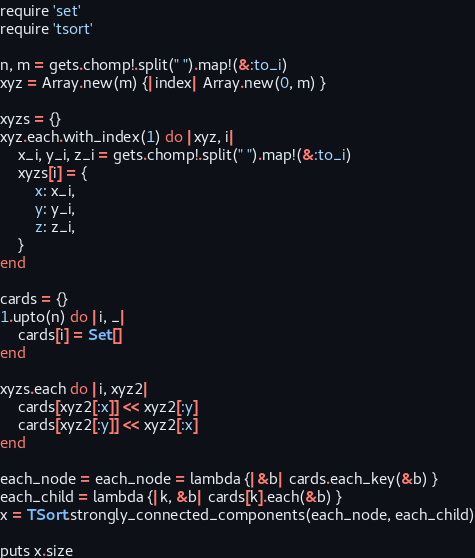<code> <loc_0><loc_0><loc_500><loc_500><_Ruby_>require 'set'
require 'tsort'

n, m = gets.chomp!.split(" ").map!(&:to_i)
xyz = Array.new(m) {|index| Array.new(0, m) }

xyzs = {}
xyz.each.with_index(1) do |xyz, i|
    x_i, y_i, z_i = gets.chomp!.split(" ").map!(&:to_i)
    xyzs[i] = {
        x: x_i,
        y: y_i,
        z: z_i,
    }
end

cards = {}
1.upto(n) do |i, _|
    cards[i] = Set[]
end

xyzs.each do |i, xyz2|
    cards[xyz2[:x]] << xyz2[:y] 
    cards[xyz2[:y]] << xyz2[:x]
end

each_node = each_node = lambda {|&b| cards.each_key(&b) }
each_child = lambda {|k, &b| cards[k].each(&b) }
x = TSort.strongly_connected_components(each_node, each_child)

puts x.size
</code> 